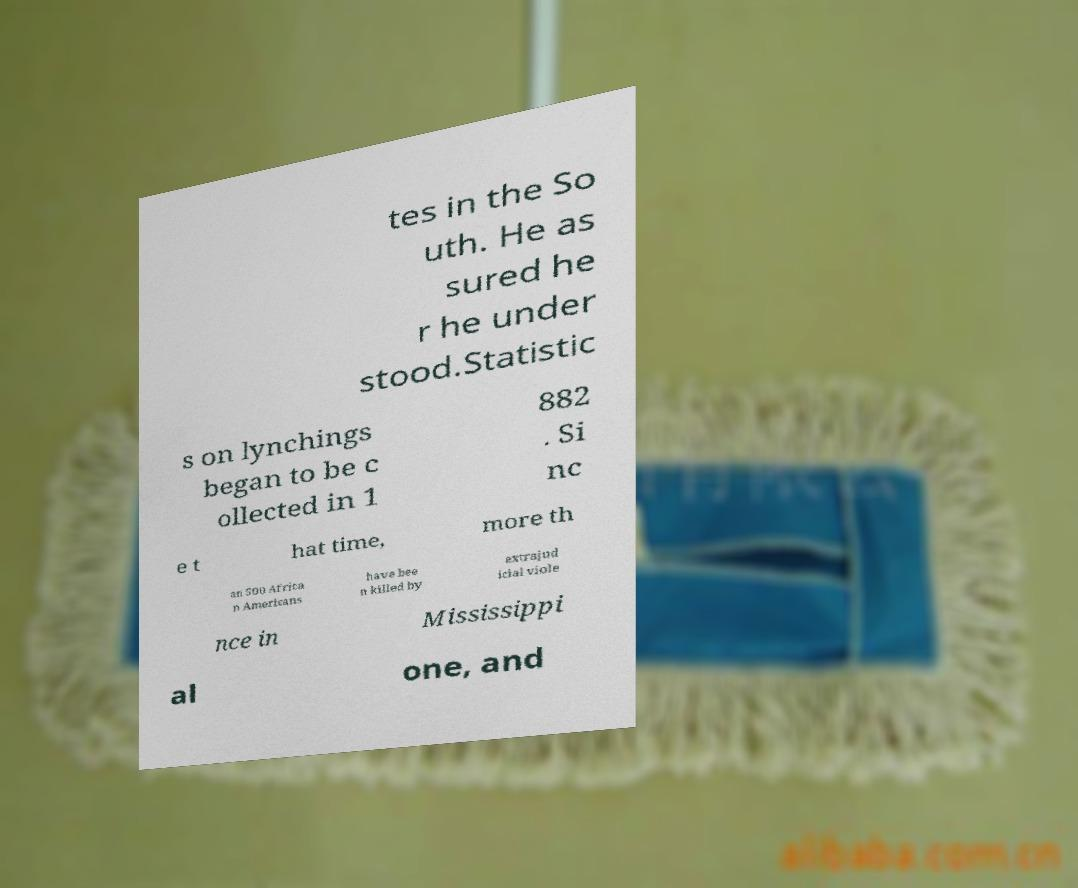What messages or text are displayed in this image? I need them in a readable, typed format. tes in the So uth. He as sured he r he under stood.Statistic s on lynchings began to be c ollected in 1 882 . Si nc e t hat time, more th an 500 Africa n Americans have bee n killed by extrajud icial viole nce in Mississippi al one, and 